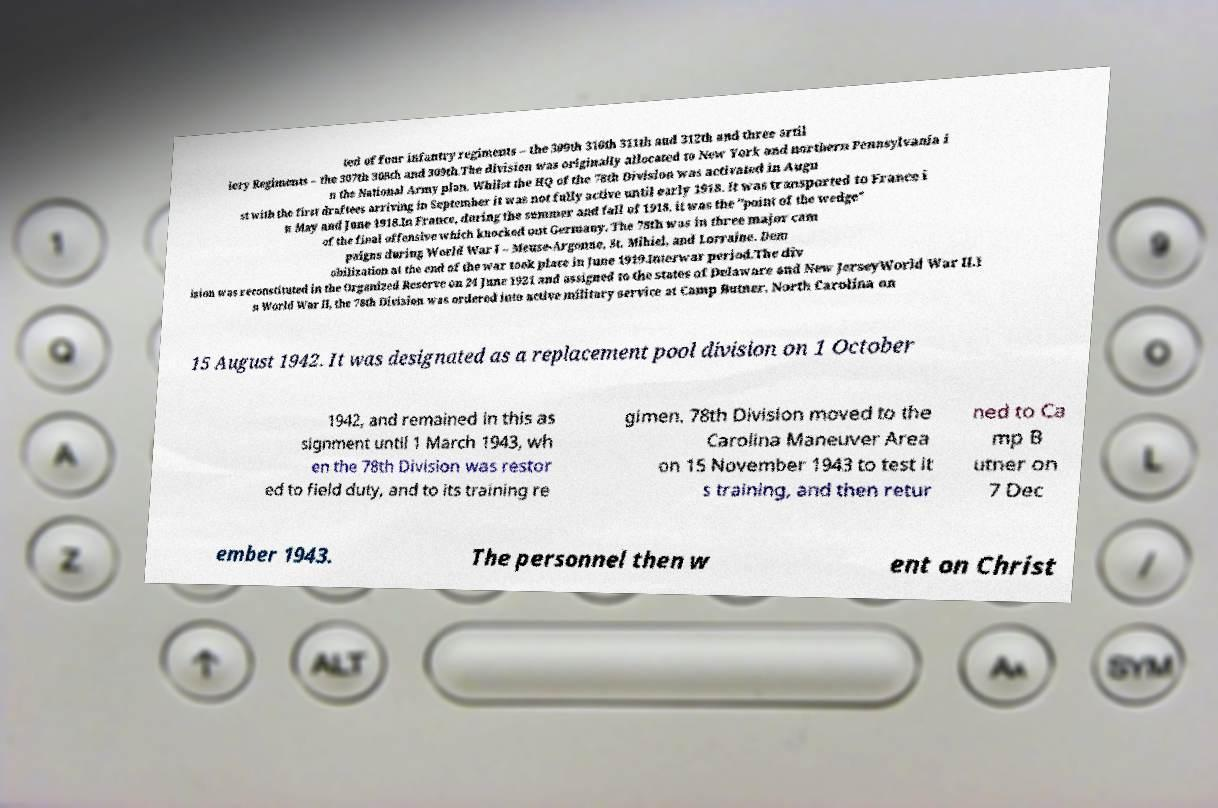There's text embedded in this image that I need extracted. Can you transcribe it verbatim? ted of four infantry regiments – the 309th 310th 311th and 312th and three artil lery Regiments – the 307th 308th and 309th.The division was originally allocated to New York and northern Pennsylvania i n the National Army plan. Whilst the HQ of the 78th Division was activated in Augu st with the first draftees arriving in September it was not fully active until early 1918. It was transported to France i n May and June 1918.In France, during the summer and fall of 1918, it was the "point of the wedge" of the final offensive which knocked out Germany. The 78th was in three major cam paigns during World War I – Meuse-Argonne, St. Mihiel, and Lorraine. Dem obilization at the end of the war took place in June 1919.Interwar period.The div ision was reconstituted in the Organized Reserve on 24 June 1921 and assigned to the states of Delaware and New JerseyWorld War II.I n World War II, the 78th Division was ordered into active military service at Camp Butner, North Carolina on 15 August 1942. It was designated as a replacement pool division on 1 October 1942, and remained in this as signment until 1 March 1943, wh en the 78th Division was restor ed to field duty, and to its training re gimen. 78th Division moved to the Carolina Maneuver Area on 15 November 1943 to test it s training, and then retur ned to Ca mp B utner on 7 Dec ember 1943. The personnel then w ent on Christ 